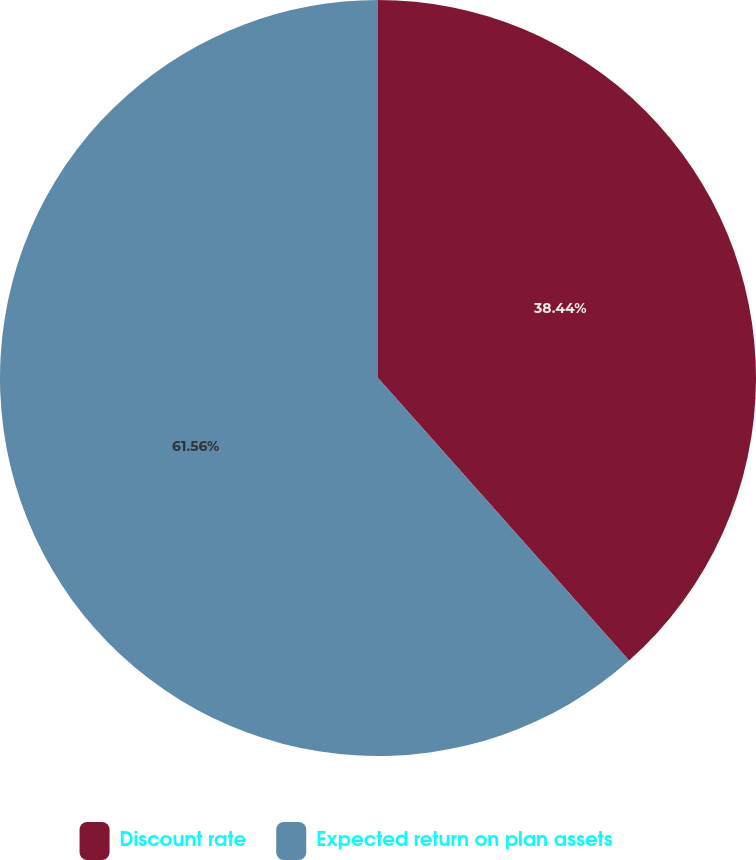<chart> <loc_0><loc_0><loc_500><loc_500><pie_chart><fcel>Discount rate<fcel>Expected return on plan assets<nl><fcel>38.44%<fcel>61.56%<nl></chart> 